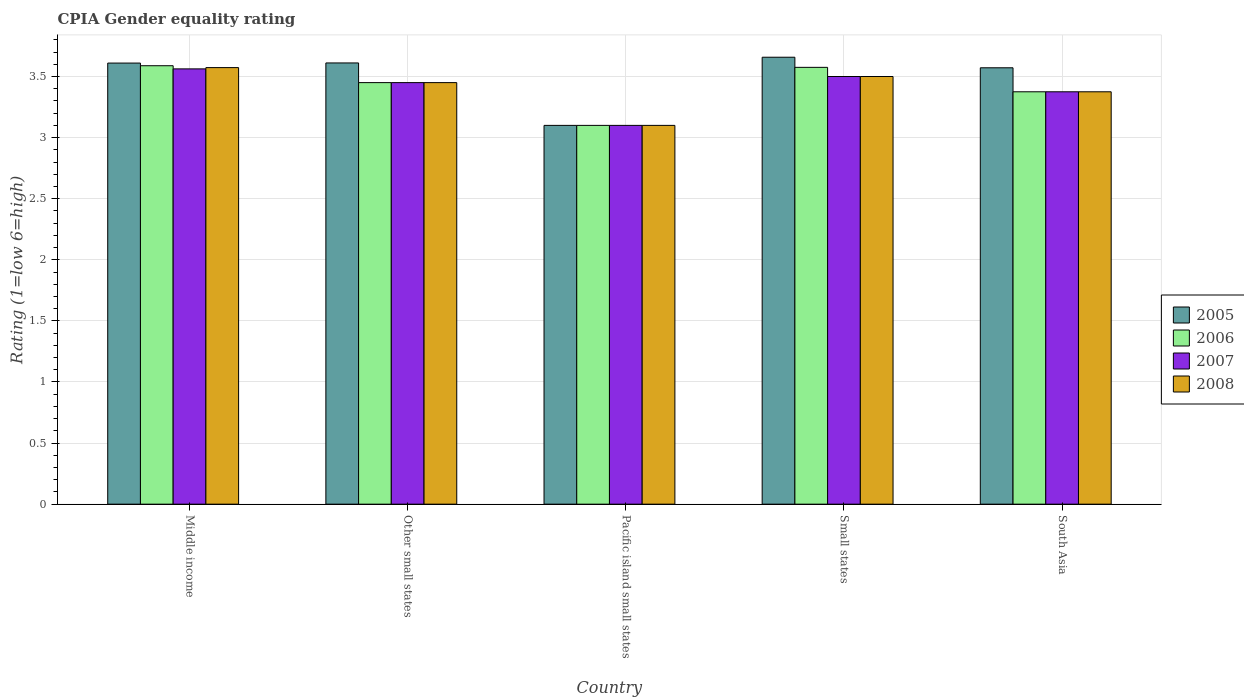How many different coloured bars are there?
Ensure brevity in your answer.  4. How many groups of bars are there?
Keep it short and to the point. 5. Are the number of bars on each tick of the X-axis equal?
Make the answer very short. Yes. How many bars are there on the 1st tick from the right?
Ensure brevity in your answer.  4. In how many cases, is the number of bars for a given country not equal to the number of legend labels?
Offer a very short reply. 0. What is the CPIA rating in 2006 in Other small states?
Your answer should be compact. 3.45. Across all countries, what is the maximum CPIA rating in 2006?
Your answer should be compact. 3.59. Across all countries, what is the minimum CPIA rating in 2005?
Provide a succinct answer. 3.1. In which country was the CPIA rating in 2005 minimum?
Offer a terse response. Pacific island small states. What is the total CPIA rating in 2006 in the graph?
Make the answer very short. 17.09. What is the difference between the CPIA rating in 2006 in Middle income and that in Other small states?
Keep it short and to the point. 0.14. What is the difference between the CPIA rating in 2005 in Other small states and the CPIA rating in 2008 in South Asia?
Your response must be concise. 0.24. What is the average CPIA rating in 2006 per country?
Make the answer very short. 3.42. What is the difference between the CPIA rating of/in 2006 and CPIA rating of/in 2005 in Small states?
Provide a succinct answer. -0.08. What is the ratio of the CPIA rating in 2006 in Middle income to that in Small states?
Make the answer very short. 1. What is the difference between the highest and the second highest CPIA rating in 2007?
Offer a terse response. -0.06. What is the difference between the highest and the lowest CPIA rating in 2005?
Provide a short and direct response. 0.56. What does the 2nd bar from the left in Other small states represents?
Keep it short and to the point. 2006. What is the difference between two consecutive major ticks on the Y-axis?
Provide a succinct answer. 0.5. Does the graph contain any zero values?
Offer a terse response. No. Does the graph contain grids?
Keep it short and to the point. Yes. Where does the legend appear in the graph?
Provide a short and direct response. Center right. How are the legend labels stacked?
Offer a terse response. Vertical. What is the title of the graph?
Offer a very short reply. CPIA Gender equality rating. What is the label or title of the X-axis?
Your answer should be compact. Country. What is the Rating (1=low 6=high) in 2005 in Middle income?
Provide a short and direct response. 3.61. What is the Rating (1=low 6=high) in 2006 in Middle income?
Provide a short and direct response. 3.59. What is the Rating (1=low 6=high) in 2007 in Middle income?
Your answer should be very brief. 3.56. What is the Rating (1=low 6=high) in 2008 in Middle income?
Give a very brief answer. 3.57. What is the Rating (1=low 6=high) of 2005 in Other small states?
Provide a short and direct response. 3.61. What is the Rating (1=low 6=high) in 2006 in Other small states?
Give a very brief answer. 3.45. What is the Rating (1=low 6=high) in 2007 in Other small states?
Your answer should be compact. 3.45. What is the Rating (1=low 6=high) of 2008 in Other small states?
Your response must be concise. 3.45. What is the Rating (1=low 6=high) of 2005 in Pacific island small states?
Provide a short and direct response. 3.1. What is the Rating (1=low 6=high) of 2006 in Pacific island small states?
Keep it short and to the point. 3.1. What is the Rating (1=low 6=high) of 2007 in Pacific island small states?
Your answer should be compact. 3.1. What is the Rating (1=low 6=high) of 2005 in Small states?
Ensure brevity in your answer.  3.66. What is the Rating (1=low 6=high) of 2006 in Small states?
Provide a succinct answer. 3.58. What is the Rating (1=low 6=high) of 2008 in Small states?
Provide a short and direct response. 3.5. What is the Rating (1=low 6=high) of 2005 in South Asia?
Your answer should be compact. 3.57. What is the Rating (1=low 6=high) of 2006 in South Asia?
Provide a short and direct response. 3.38. What is the Rating (1=low 6=high) of 2007 in South Asia?
Your response must be concise. 3.38. What is the Rating (1=low 6=high) in 2008 in South Asia?
Provide a succinct answer. 3.38. Across all countries, what is the maximum Rating (1=low 6=high) of 2005?
Make the answer very short. 3.66. Across all countries, what is the maximum Rating (1=low 6=high) of 2006?
Keep it short and to the point. 3.59. Across all countries, what is the maximum Rating (1=low 6=high) in 2007?
Your answer should be compact. 3.56. Across all countries, what is the maximum Rating (1=low 6=high) of 2008?
Keep it short and to the point. 3.57. Across all countries, what is the minimum Rating (1=low 6=high) in 2005?
Offer a terse response. 3.1. Across all countries, what is the minimum Rating (1=low 6=high) of 2006?
Offer a terse response. 3.1. What is the total Rating (1=low 6=high) in 2005 in the graph?
Provide a succinct answer. 17.55. What is the total Rating (1=low 6=high) of 2006 in the graph?
Make the answer very short. 17.09. What is the total Rating (1=low 6=high) in 2007 in the graph?
Offer a very short reply. 16.99. What is the total Rating (1=low 6=high) in 2008 in the graph?
Offer a terse response. 17. What is the difference between the Rating (1=low 6=high) of 2005 in Middle income and that in Other small states?
Provide a succinct answer. -0. What is the difference between the Rating (1=low 6=high) of 2006 in Middle income and that in Other small states?
Offer a terse response. 0.14. What is the difference between the Rating (1=low 6=high) in 2007 in Middle income and that in Other small states?
Offer a terse response. 0.11. What is the difference between the Rating (1=low 6=high) in 2008 in Middle income and that in Other small states?
Provide a short and direct response. 0.12. What is the difference between the Rating (1=low 6=high) of 2005 in Middle income and that in Pacific island small states?
Offer a terse response. 0.51. What is the difference between the Rating (1=low 6=high) of 2006 in Middle income and that in Pacific island small states?
Offer a very short reply. 0.49. What is the difference between the Rating (1=low 6=high) in 2007 in Middle income and that in Pacific island small states?
Make the answer very short. 0.46. What is the difference between the Rating (1=low 6=high) in 2008 in Middle income and that in Pacific island small states?
Provide a short and direct response. 0.47. What is the difference between the Rating (1=low 6=high) in 2005 in Middle income and that in Small states?
Give a very brief answer. -0.05. What is the difference between the Rating (1=low 6=high) of 2006 in Middle income and that in Small states?
Your answer should be very brief. 0.01. What is the difference between the Rating (1=low 6=high) of 2007 in Middle income and that in Small states?
Your answer should be compact. 0.06. What is the difference between the Rating (1=low 6=high) in 2008 in Middle income and that in Small states?
Provide a short and direct response. 0.07. What is the difference between the Rating (1=low 6=high) of 2005 in Middle income and that in South Asia?
Offer a very short reply. 0.04. What is the difference between the Rating (1=low 6=high) of 2006 in Middle income and that in South Asia?
Provide a succinct answer. 0.21. What is the difference between the Rating (1=low 6=high) in 2007 in Middle income and that in South Asia?
Offer a terse response. 0.19. What is the difference between the Rating (1=low 6=high) in 2008 in Middle income and that in South Asia?
Offer a terse response. 0.2. What is the difference between the Rating (1=low 6=high) in 2005 in Other small states and that in Pacific island small states?
Your response must be concise. 0.51. What is the difference between the Rating (1=low 6=high) in 2008 in Other small states and that in Pacific island small states?
Offer a very short reply. 0.35. What is the difference between the Rating (1=low 6=high) in 2005 in Other small states and that in Small states?
Provide a succinct answer. -0.05. What is the difference between the Rating (1=low 6=high) of 2006 in Other small states and that in Small states?
Your answer should be compact. -0.12. What is the difference between the Rating (1=low 6=high) in 2005 in Other small states and that in South Asia?
Your answer should be compact. 0.04. What is the difference between the Rating (1=low 6=high) in 2006 in Other small states and that in South Asia?
Provide a succinct answer. 0.07. What is the difference between the Rating (1=low 6=high) in 2007 in Other small states and that in South Asia?
Provide a short and direct response. 0.07. What is the difference between the Rating (1=low 6=high) in 2008 in Other small states and that in South Asia?
Provide a short and direct response. 0.07. What is the difference between the Rating (1=low 6=high) of 2005 in Pacific island small states and that in Small states?
Make the answer very short. -0.56. What is the difference between the Rating (1=low 6=high) of 2006 in Pacific island small states and that in Small states?
Your answer should be very brief. -0.47. What is the difference between the Rating (1=low 6=high) of 2008 in Pacific island small states and that in Small states?
Provide a succinct answer. -0.4. What is the difference between the Rating (1=low 6=high) of 2005 in Pacific island small states and that in South Asia?
Offer a terse response. -0.47. What is the difference between the Rating (1=low 6=high) of 2006 in Pacific island small states and that in South Asia?
Provide a succinct answer. -0.28. What is the difference between the Rating (1=low 6=high) of 2007 in Pacific island small states and that in South Asia?
Your answer should be compact. -0.28. What is the difference between the Rating (1=low 6=high) of 2008 in Pacific island small states and that in South Asia?
Your response must be concise. -0.28. What is the difference between the Rating (1=low 6=high) in 2005 in Small states and that in South Asia?
Your answer should be compact. 0.09. What is the difference between the Rating (1=low 6=high) of 2007 in Small states and that in South Asia?
Your answer should be compact. 0.12. What is the difference between the Rating (1=low 6=high) of 2005 in Middle income and the Rating (1=low 6=high) of 2006 in Other small states?
Make the answer very short. 0.16. What is the difference between the Rating (1=low 6=high) in 2005 in Middle income and the Rating (1=low 6=high) in 2007 in Other small states?
Ensure brevity in your answer.  0.16. What is the difference between the Rating (1=low 6=high) in 2005 in Middle income and the Rating (1=low 6=high) in 2008 in Other small states?
Provide a short and direct response. 0.16. What is the difference between the Rating (1=low 6=high) of 2006 in Middle income and the Rating (1=low 6=high) of 2007 in Other small states?
Keep it short and to the point. 0.14. What is the difference between the Rating (1=low 6=high) in 2006 in Middle income and the Rating (1=low 6=high) in 2008 in Other small states?
Your answer should be very brief. 0.14. What is the difference between the Rating (1=low 6=high) of 2007 in Middle income and the Rating (1=low 6=high) of 2008 in Other small states?
Offer a terse response. 0.11. What is the difference between the Rating (1=low 6=high) of 2005 in Middle income and the Rating (1=low 6=high) of 2006 in Pacific island small states?
Provide a succinct answer. 0.51. What is the difference between the Rating (1=low 6=high) in 2005 in Middle income and the Rating (1=low 6=high) in 2007 in Pacific island small states?
Keep it short and to the point. 0.51. What is the difference between the Rating (1=low 6=high) in 2005 in Middle income and the Rating (1=low 6=high) in 2008 in Pacific island small states?
Provide a short and direct response. 0.51. What is the difference between the Rating (1=low 6=high) in 2006 in Middle income and the Rating (1=low 6=high) in 2007 in Pacific island small states?
Provide a short and direct response. 0.49. What is the difference between the Rating (1=low 6=high) in 2006 in Middle income and the Rating (1=low 6=high) in 2008 in Pacific island small states?
Offer a terse response. 0.49. What is the difference between the Rating (1=low 6=high) of 2007 in Middle income and the Rating (1=low 6=high) of 2008 in Pacific island small states?
Provide a succinct answer. 0.46. What is the difference between the Rating (1=low 6=high) of 2005 in Middle income and the Rating (1=low 6=high) of 2006 in Small states?
Your answer should be compact. 0.04. What is the difference between the Rating (1=low 6=high) in 2005 in Middle income and the Rating (1=low 6=high) in 2007 in Small states?
Provide a succinct answer. 0.11. What is the difference between the Rating (1=low 6=high) in 2005 in Middle income and the Rating (1=low 6=high) in 2008 in Small states?
Make the answer very short. 0.11. What is the difference between the Rating (1=low 6=high) of 2006 in Middle income and the Rating (1=low 6=high) of 2007 in Small states?
Your response must be concise. 0.09. What is the difference between the Rating (1=low 6=high) of 2006 in Middle income and the Rating (1=low 6=high) of 2008 in Small states?
Offer a very short reply. 0.09. What is the difference between the Rating (1=low 6=high) of 2007 in Middle income and the Rating (1=low 6=high) of 2008 in Small states?
Your answer should be very brief. 0.06. What is the difference between the Rating (1=low 6=high) of 2005 in Middle income and the Rating (1=low 6=high) of 2006 in South Asia?
Provide a succinct answer. 0.23. What is the difference between the Rating (1=low 6=high) in 2005 in Middle income and the Rating (1=low 6=high) in 2007 in South Asia?
Provide a short and direct response. 0.23. What is the difference between the Rating (1=low 6=high) in 2005 in Middle income and the Rating (1=low 6=high) in 2008 in South Asia?
Your answer should be compact. 0.23. What is the difference between the Rating (1=low 6=high) of 2006 in Middle income and the Rating (1=low 6=high) of 2007 in South Asia?
Your response must be concise. 0.21. What is the difference between the Rating (1=low 6=high) of 2006 in Middle income and the Rating (1=low 6=high) of 2008 in South Asia?
Keep it short and to the point. 0.21. What is the difference between the Rating (1=low 6=high) of 2007 in Middle income and the Rating (1=low 6=high) of 2008 in South Asia?
Keep it short and to the point. 0.19. What is the difference between the Rating (1=low 6=high) in 2005 in Other small states and the Rating (1=low 6=high) in 2006 in Pacific island small states?
Offer a very short reply. 0.51. What is the difference between the Rating (1=low 6=high) of 2005 in Other small states and the Rating (1=low 6=high) of 2007 in Pacific island small states?
Make the answer very short. 0.51. What is the difference between the Rating (1=low 6=high) in 2005 in Other small states and the Rating (1=low 6=high) in 2008 in Pacific island small states?
Give a very brief answer. 0.51. What is the difference between the Rating (1=low 6=high) in 2006 in Other small states and the Rating (1=low 6=high) in 2007 in Pacific island small states?
Keep it short and to the point. 0.35. What is the difference between the Rating (1=low 6=high) in 2005 in Other small states and the Rating (1=low 6=high) in 2006 in Small states?
Your answer should be compact. 0.04. What is the difference between the Rating (1=low 6=high) in 2005 in Other small states and the Rating (1=low 6=high) in 2007 in Small states?
Keep it short and to the point. 0.11. What is the difference between the Rating (1=low 6=high) in 2005 in Other small states and the Rating (1=low 6=high) in 2008 in Small states?
Provide a succinct answer. 0.11. What is the difference between the Rating (1=low 6=high) of 2006 in Other small states and the Rating (1=low 6=high) of 2007 in Small states?
Provide a short and direct response. -0.05. What is the difference between the Rating (1=low 6=high) in 2007 in Other small states and the Rating (1=low 6=high) in 2008 in Small states?
Give a very brief answer. -0.05. What is the difference between the Rating (1=low 6=high) in 2005 in Other small states and the Rating (1=low 6=high) in 2006 in South Asia?
Your answer should be compact. 0.24. What is the difference between the Rating (1=low 6=high) in 2005 in Other small states and the Rating (1=low 6=high) in 2007 in South Asia?
Give a very brief answer. 0.24. What is the difference between the Rating (1=low 6=high) of 2005 in Other small states and the Rating (1=low 6=high) of 2008 in South Asia?
Provide a short and direct response. 0.24. What is the difference between the Rating (1=low 6=high) in 2006 in Other small states and the Rating (1=low 6=high) in 2007 in South Asia?
Your response must be concise. 0.07. What is the difference between the Rating (1=low 6=high) of 2006 in Other small states and the Rating (1=low 6=high) of 2008 in South Asia?
Provide a short and direct response. 0.07. What is the difference between the Rating (1=low 6=high) of 2007 in Other small states and the Rating (1=low 6=high) of 2008 in South Asia?
Your response must be concise. 0.07. What is the difference between the Rating (1=low 6=high) of 2005 in Pacific island small states and the Rating (1=low 6=high) of 2006 in Small states?
Ensure brevity in your answer.  -0.47. What is the difference between the Rating (1=low 6=high) in 2006 in Pacific island small states and the Rating (1=low 6=high) in 2007 in Small states?
Your response must be concise. -0.4. What is the difference between the Rating (1=low 6=high) of 2007 in Pacific island small states and the Rating (1=low 6=high) of 2008 in Small states?
Keep it short and to the point. -0.4. What is the difference between the Rating (1=low 6=high) in 2005 in Pacific island small states and the Rating (1=low 6=high) in 2006 in South Asia?
Offer a terse response. -0.28. What is the difference between the Rating (1=low 6=high) of 2005 in Pacific island small states and the Rating (1=low 6=high) of 2007 in South Asia?
Give a very brief answer. -0.28. What is the difference between the Rating (1=low 6=high) of 2005 in Pacific island small states and the Rating (1=low 6=high) of 2008 in South Asia?
Your answer should be compact. -0.28. What is the difference between the Rating (1=low 6=high) of 2006 in Pacific island small states and the Rating (1=low 6=high) of 2007 in South Asia?
Make the answer very short. -0.28. What is the difference between the Rating (1=low 6=high) in 2006 in Pacific island small states and the Rating (1=low 6=high) in 2008 in South Asia?
Your answer should be very brief. -0.28. What is the difference between the Rating (1=low 6=high) of 2007 in Pacific island small states and the Rating (1=low 6=high) of 2008 in South Asia?
Give a very brief answer. -0.28. What is the difference between the Rating (1=low 6=high) of 2005 in Small states and the Rating (1=low 6=high) of 2006 in South Asia?
Keep it short and to the point. 0.28. What is the difference between the Rating (1=low 6=high) in 2005 in Small states and the Rating (1=low 6=high) in 2007 in South Asia?
Make the answer very short. 0.28. What is the difference between the Rating (1=low 6=high) in 2005 in Small states and the Rating (1=low 6=high) in 2008 in South Asia?
Make the answer very short. 0.28. What is the difference between the Rating (1=low 6=high) of 2006 in Small states and the Rating (1=low 6=high) of 2007 in South Asia?
Offer a terse response. 0.2. What is the difference between the Rating (1=low 6=high) of 2006 in Small states and the Rating (1=low 6=high) of 2008 in South Asia?
Your answer should be compact. 0.2. What is the difference between the Rating (1=low 6=high) of 2007 in Small states and the Rating (1=low 6=high) of 2008 in South Asia?
Your answer should be compact. 0.12. What is the average Rating (1=low 6=high) of 2005 per country?
Provide a short and direct response. 3.51. What is the average Rating (1=low 6=high) in 2006 per country?
Make the answer very short. 3.42. What is the average Rating (1=low 6=high) in 2007 per country?
Your answer should be very brief. 3.4. What is the average Rating (1=low 6=high) in 2008 per country?
Ensure brevity in your answer.  3.4. What is the difference between the Rating (1=low 6=high) of 2005 and Rating (1=low 6=high) of 2006 in Middle income?
Your answer should be very brief. 0.02. What is the difference between the Rating (1=low 6=high) of 2005 and Rating (1=low 6=high) of 2007 in Middle income?
Keep it short and to the point. 0.05. What is the difference between the Rating (1=low 6=high) of 2005 and Rating (1=low 6=high) of 2008 in Middle income?
Give a very brief answer. 0.04. What is the difference between the Rating (1=low 6=high) of 2006 and Rating (1=low 6=high) of 2007 in Middle income?
Provide a succinct answer. 0.03. What is the difference between the Rating (1=low 6=high) of 2006 and Rating (1=low 6=high) of 2008 in Middle income?
Ensure brevity in your answer.  0.02. What is the difference between the Rating (1=low 6=high) in 2007 and Rating (1=low 6=high) in 2008 in Middle income?
Keep it short and to the point. -0.01. What is the difference between the Rating (1=low 6=high) in 2005 and Rating (1=low 6=high) in 2006 in Other small states?
Keep it short and to the point. 0.16. What is the difference between the Rating (1=low 6=high) in 2005 and Rating (1=low 6=high) in 2007 in Other small states?
Provide a short and direct response. 0.16. What is the difference between the Rating (1=low 6=high) in 2005 and Rating (1=low 6=high) in 2008 in Other small states?
Your answer should be very brief. 0.16. What is the difference between the Rating (1=low 6=high) in 2006 and Rating (1=low 6=high) in 2007 in Other small states?
Offer a terse response. 0. What is the difference between the Rating (1=low 6=high) of 2005 and Rating (1=low 6=high) of 2006 in Pacific island small states?
Your answer should be compact. 0. What is the difference between the Rating (1=low 6=high) in 2006 and Rating (1=low 6=high) in 2007 in Pacific island small states?
Provide a succinct answer. 0. What is the difference between the Rating (1=low 6=high) of 2006 and Rating (1=low 6=high) of 2008 in Pacific island small states?
Give a very brief answer. 0. What is the difference between the Rating (1=low 6=high) in 2005 and Rating (1=low 6=high) in 2006 in Small states?
Give a very brief answer. 0.08. What is the difference between the Rating (1=low 6=high) of 2005 and Rating (1=low 6=high) of 2007 in Small states?
Your answer should be compact. 0.16. What is the difference between the Rating (1=low 6=high) of 2005 and Rating (1=low 6=high) of 2008 in Small states?
Give a very brief answer. 0.16. What is the difference between the Rating (1=low 6=high) in 2006 and Rating (1=low 6=high) in 2007 in Small states?
Ensure brevity in your answer.  0.07. What is the difference between the Rating (1=low 6=high) in 2006 and Rating (1=low 6=high) in 2008 in Small states?
Offer a terse response. 0.07. What is the difference between the Rating (1=low 6=high) of 2007 and Rating (1=low 6=high) of 2008 in Small states?
Ensure brevity in your answer.  0. What is the difference between the Rating (1=low 6=high) of 2005 and Rating (1=low 6=high) of 2006 in South Asia?
Make the answer very short. 0.2. What is the difference between the Rating (1=low 6=high) of 2005 and Rating (1=low 6=high) of 2007 in South Asia?
Provide a succinct answer. 0.2. What is the difference between the Rating (1=low 6=high) in 2005 and Rating (1=low 6=high) in 2008 in South Asia?
Provide a short and direct response. 0.2. What is the ratio of the Rating (1=low 6=high) in 2005 in Middle income to that in Other small states?
Ensure brevity in your answer.  1. What is the ratio of the Rating (1=low 6=high) of 2006 in Middle income to that in Other small states?
Make the answer very short. 1.04. What is the ratio of the Rating (1=low 6=high) of 2007 in Middle income to that in Other small states?
Offer a very short reply. 1.03. What is the ratio of the Rating (1=low 6=high) of 2008 in Middle income to that in Other small states?
Provide a succinct answer. 1.04. What is the ratio of the Rating (1=low 6=high) in 2005 in Middle income to that in Pacific island small states?
Your answer should be compact. 1.16. What is the ratio of the Rating (1=low 6=high) in 2006 in Middle income to that in Pacific island small states?
Keep it short and to the point. 1.16. What is the ratio of the Rating (1=low 6=high) of 2007 in Middle income to that in Pacific island small states?
Provide a succinct answer. 1.15. What is the ratio of the Rating (1=low 6=high) in 2008 in Middle income to that in Pacific island small states?
Your response must be concise. 1.15. What is the ratio of the Rating (1=low 6=high) in 2005 in Middle income to that in Small states?
Your answer should be compact. 0.99. What is the ratio of the Rating (1=low 6=high) of 2006 in Middle income to that in Small states?
Keep it short and to the point. 1. What is the ratio of the Rating (1=low 6=high) of 2007 in Middle income to that in Small states?
Provide a short and direct response. 1.02. What is the ratio of the Rating (1=low 6=high) of 2008 in Middle income to that in Small states?
Make the answer very short. 1.02. What is the ratio of the Rating (1=low 6=high) of 2005 in Middle income to that in South Asia?
Offer a very short reply. 1.01. What is the ratio of the Rating (1=low 6=high) of 2006 in Middle income to that in South Asia?
Provide a short and direct response. 1.06. What is the ratio of the Rating (1=low 6=high) of 2007 in Middle income to that in South Asia?
Offer a very short reply. 1.06. What is the ratio of the Rating (1=low 6=high) in 2008 in Middle income to that in South Asia?
Keep it short and to the point. 1.06. What is the ratio of the Rating (1=low 6=high) in 2005 in Other small states to that in Pacific island small states?
Provide a short and direct response. 1.16. What is the ratio of the Rating (1=low 6=high) in 2006 in Other small states to that in Pacific island small states?
Offer a terse response. 1.11. What is the ratio of the Rating (1=low 6=high) in 2007 in Other small states to that in Pacific island small states?
Your response must be concise. 1.11. What is the ratio of the Rating (1=low 6=high) in 2008 in Other small states to that in Pacific island small states?
Keep it short and to the point. 1.11. What is the ratio of the Rating (1=low 6=high) in 2005 in Other small states to that in Small states?
Provide a succinct answer. 0.99. What is the ratio of the Rating (1=low 6=high) in 2006 in Other small states to that in Small states?
Your answer should be compact. 0.96. What is the ratio of the Rating (1=low 6=high) of 2007 in Other small states to that in Small states?
Ensure brevity in your answer.  0.99. What is the ratio of the Rating (1=low 6=high) in 2008 in Other small states to that in Small states?
Your answer should be very brief. 0.99. What is the ratio of the Rating (1=low 6=high) of 2005 in Other small states to that in South Asia?
Your response must be concise. 1.01. What is the ratio of the Rating (1=low 6=high) in 2006 in Other small states to that in South Asia?
Offer a very short reply. 1.02. What is the ratio of the Rating (1=low 6=high) of 2007 in Other small states to that in South Asia?
Make the answer very short. 1.02. What is the ratio of the Rating (1=low 6=high) in 2008 in Other small states to that in South Asia?
Keep it short and to the point. 1.02. What is the ratio of the Rating (1=low 6=high) of 2005 in Pacific island small states to that in Small states?
Give a very brief answer. 0.85. What is the ratio of the Rating (1=low 6=high) in 2006 in Pacific island small states to that in Small states?
Provide a short and direct response. 0.87. What is the ratio of the Rating (1=low 6=high) in 2007 in Pacific island small states to that in Small states?
Keep it short and to the point. 0.89. What is the ratio of the Rating (1=low 6=high) of 2008 in Pacific island small states to that in Small states?
Your answer should be very brief. 0.89. What is the ratio of the Rating (1=low 6=high) in 2005 in Pacific island small states to that in South Asia?
Offer a terse response. 0.87. What is the ratio of the Rating (1=low 6=high) in 2006 in Pacific island small states to that in South Asia?
Provide a short and direct response. 0.92. What is the ratio of the Rating (1=low 6=high) of 2007 in Pacific island small states to that in South Asia?
Your answer should be compact. 0.92. What is the ratio of the Rating (1=low 6=high) of 2008 in Pacific island small states to that in South Asia?
Offer a terse response. 0.92. What is the ratio of the Rating (1=low 6=high) of 2005 in Small states to that in South Asia?
Ensure brevity in your answer.  1.02. What is the ratio of the Rating (1=low 6=high) of 2006 in Small states to that in South Asia?
Keep it short and to the point. 1.06. What is the ratio of the Rating (1=low 6=high) of 2008 in Small states to that in South Asia?
Provide a short and direct response. 1.04. What is the difference between the highest and the second highest Rating (1=low 6=high) in 2005?
Ensure brevity in your answer.  0.05. What is the difference between the highest and the second highest Rating (1=low 6=high) of 2006?
Keep it short and to the point. 0.01. What is the difference between the highest and the second highest Rating (1=low 6=high) in 2007?
Offer a terse response. 0.06. What is the difference between the highest and the second highest Rating (1=low 6=high) in 2008?
Provide a succinct answer. 0.07. What is the difference between the highest and the lowest Rating (1=low 6=high) in 2005?
Keep it short and to the point. 0.56. What is the difference between the highest and the lowest Rating (1=low 6=high) in 2006?
Provide a short and direct response. 0.49. What is the difference between the highest and the lowest Rating (1=low 6=high) in 2007?
Your answer should be very brief. 0.46. What is the difference between the highest and the lowest Rating (1=low 6=high) in 2008?
Give a very brief answer. 0.47. 